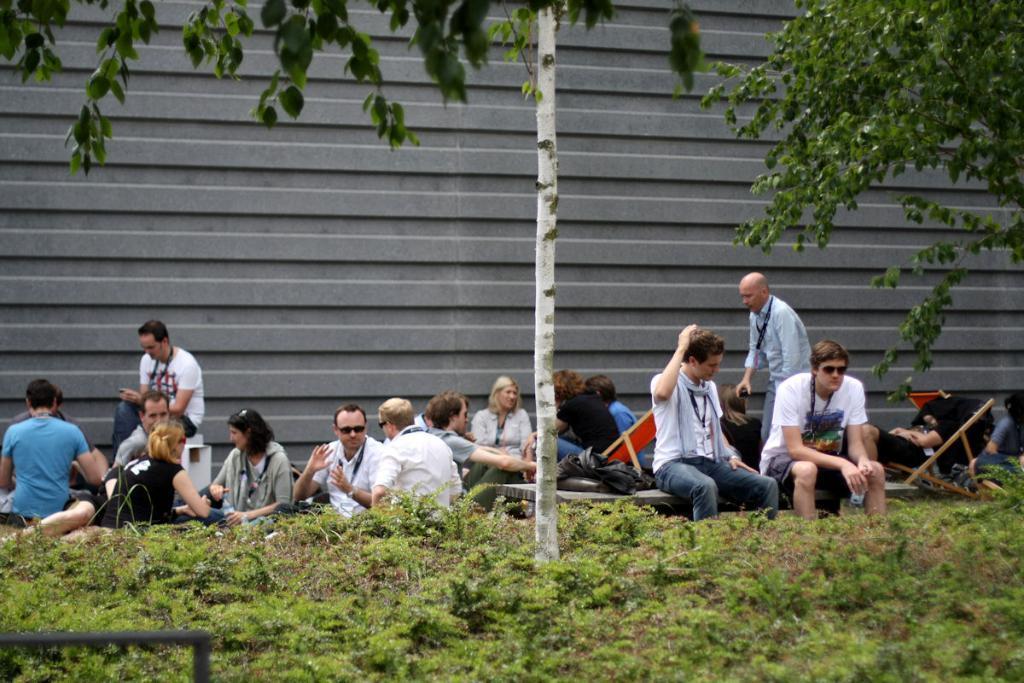In one or two sentences, can you explain what this image depicts? In this image there are a few people sitting on the surface of the grass and there are few objects, behind them there is a wall. At the top of the image we can see the leaves of a tree. 